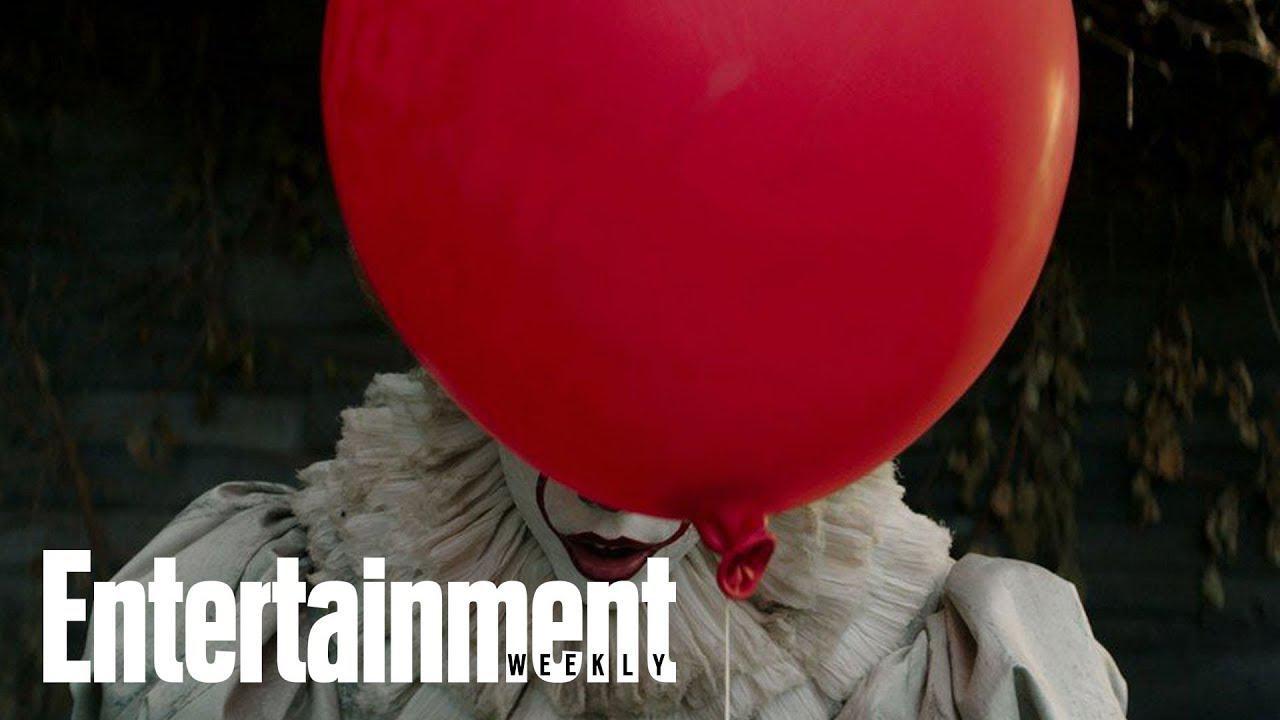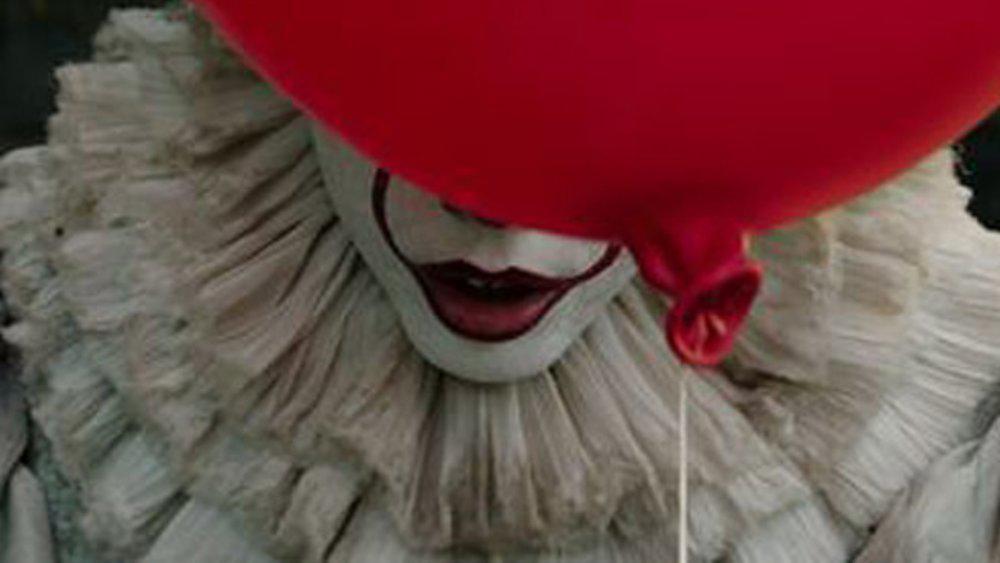The first image is the image on the left, the second image is the image on the right. For the images displayed, is the sentence "There are four eyes." factually correct? Answer yes or no. No. 